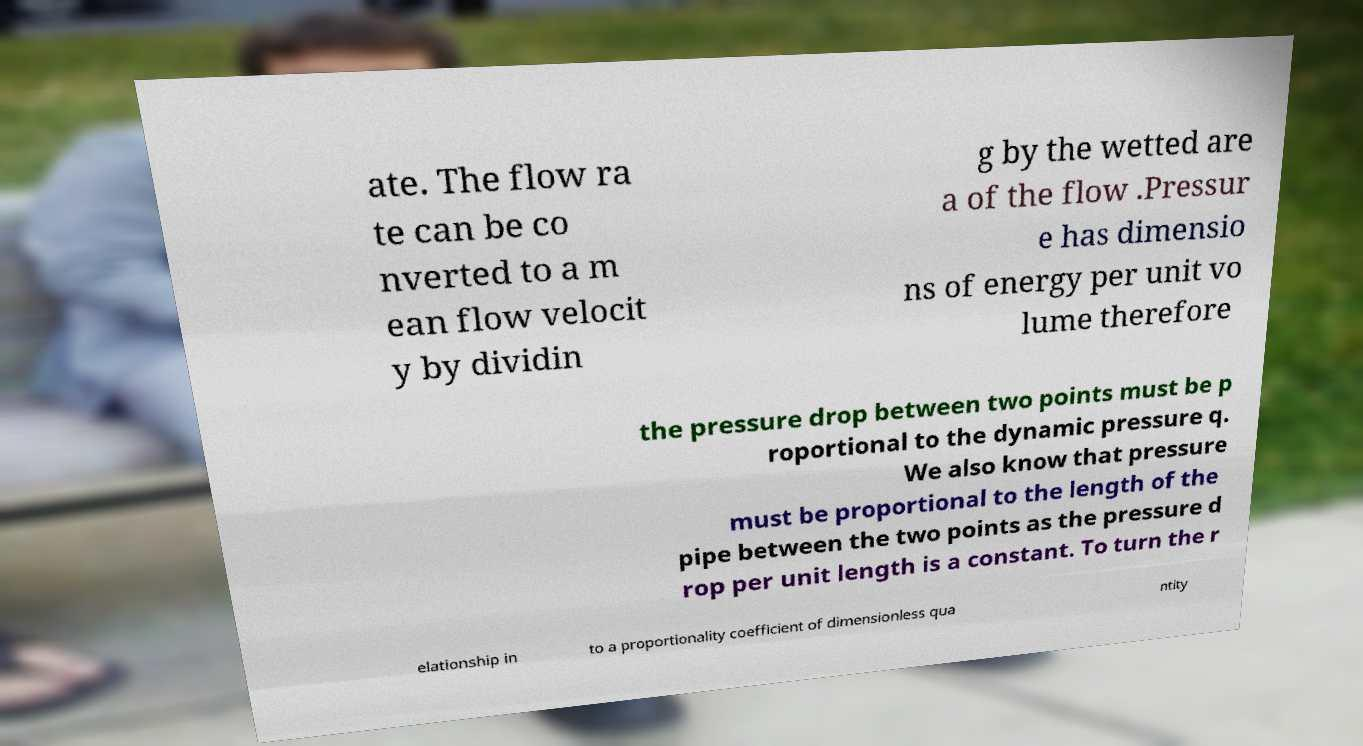For documentation purposes, I need the text within this image transcribed. Could you provide that? ate. The flow ra te can be co nverted to a m ean flow velocit y by dividin g by the wetted are a of the flow .Pressur e has dimensio ns of energy per unit vo lume therefore the pressure drop between two points must be p roportional to the dynamic pressure q. We also know that pressure must be proportional to the length of the pipe between the two points as the pressure d rop per unit length is a constant. To turn the r elationship in to a proportionality coefficient of dimensionless qua ntity 